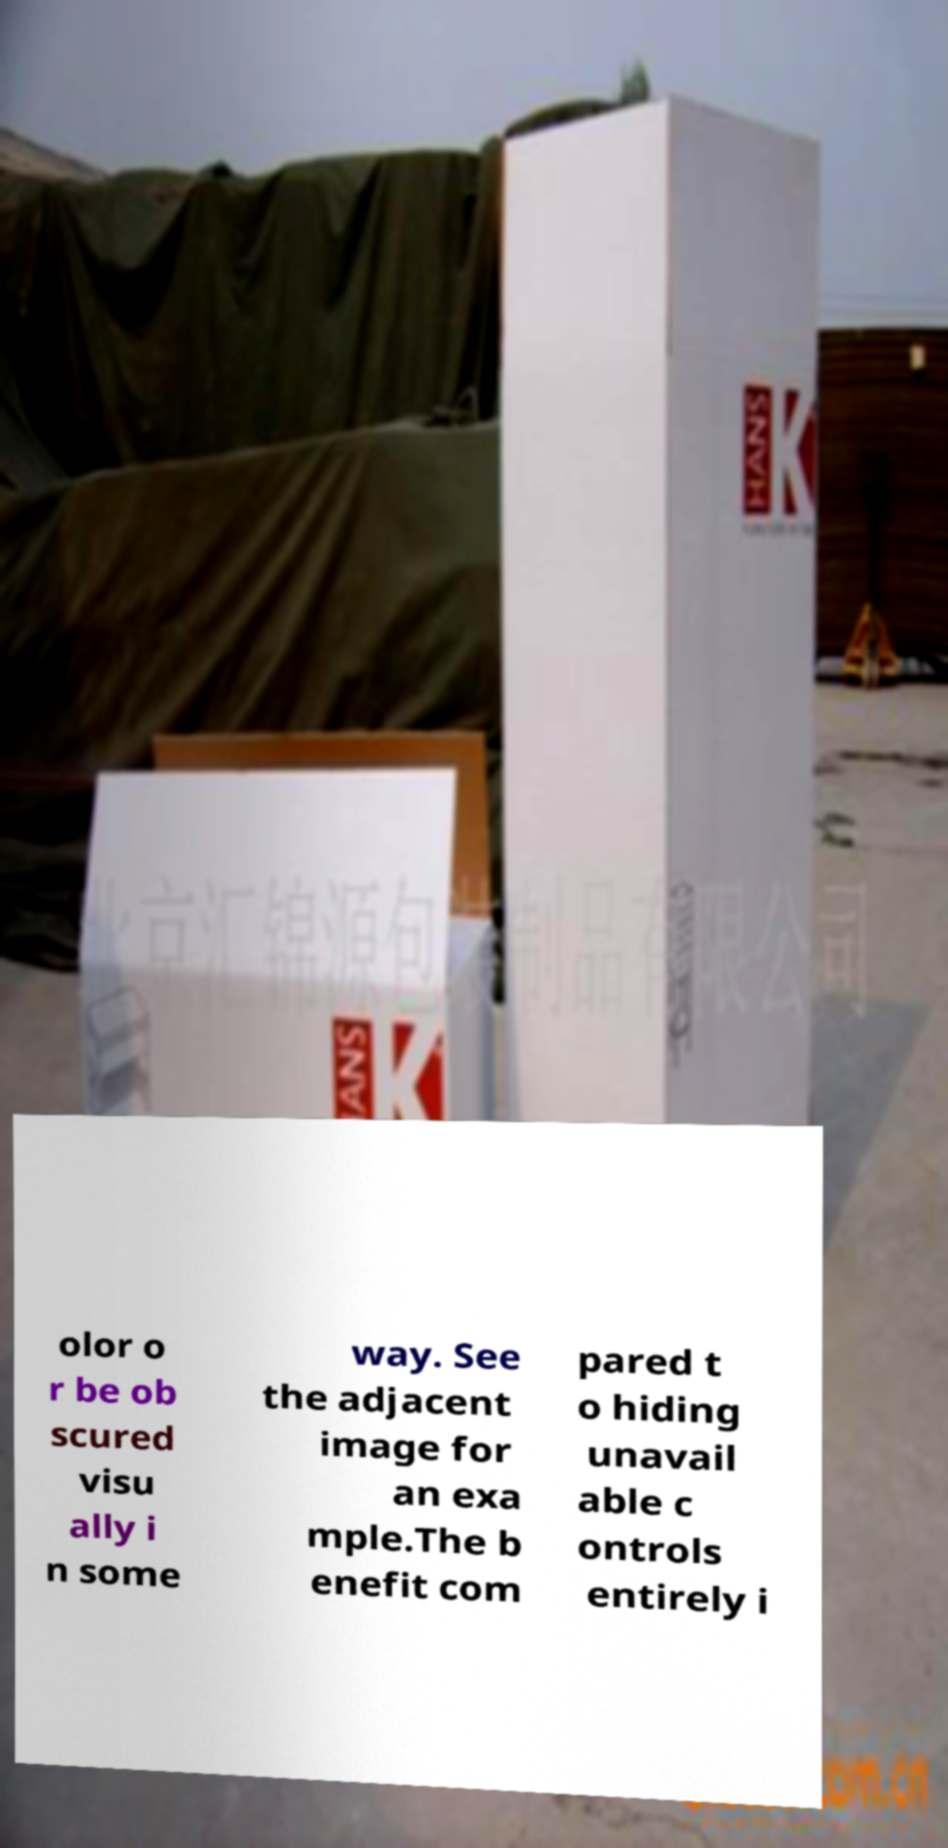There's text embedded in this image that I need extracted. Can you transcribe it verbatim? olor o r be ob scured visu ally i n some way. See the adjacent image for an exa mple.The b enefit com pared t o hiding unavail able c ontrols entirely i 